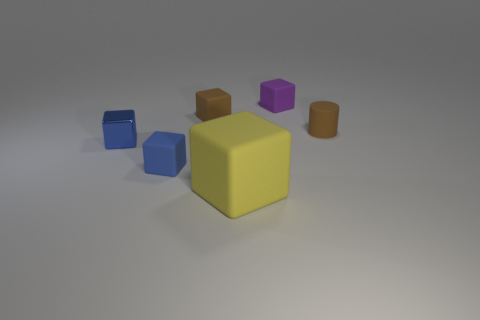Subtract all cyan cubes. Subtract all red cylinders. How many cubes are left? 5 Add 2 small blue rubber blocks. How many objects exist? 8 Subtract all cylinders. How many objects are left? 5 Add 5 brown matte blocks. How many brown matte blocks exist? 6 Subtract 0 blue balls. How many objects are left? 6 Subtract all small brown matte objects. Subtract all cyan shiny blocks. How many objects are left? 4 Add 3 matte things. How many matte things are left? 8 